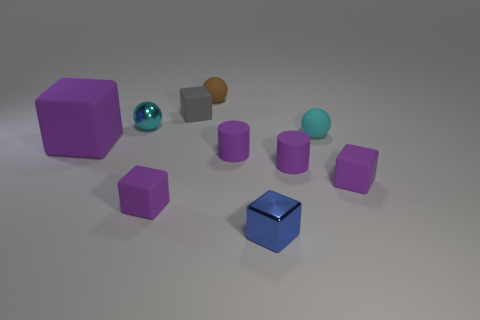What color is the small rubber cube to the right of the rubber ball to the right of the brown rubber ball? The small rubber cube located to the right of the teal rubber ball, which in turn is to the right of the brown rubber ball, is purple. 